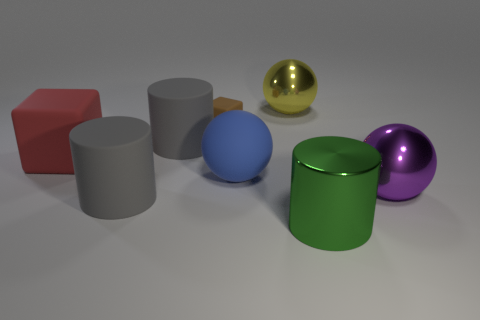How many gray cylinders must be subtracted to get 1 gray cylinders? 1 Subtract all rubber cylinders. How many cylinders are left? 1 Add 1 tiny matte objects. How many objects exist? 9 Subtract all red cubes. How many cubes are left? 1 Subtract 3 balls. How many balls are left? 0 Subtract all red balls. How many gray cylinders are left? 2 Add 2 green cylinders. How many green cylinders are left? 3 Add 8 large yellow rubber blocks. How many large yellow rubber blocks exist? 8 Subtract 0 yellow cylinders. How many objects are left? 8 Subtract all blocks. How many objects are left? 6 